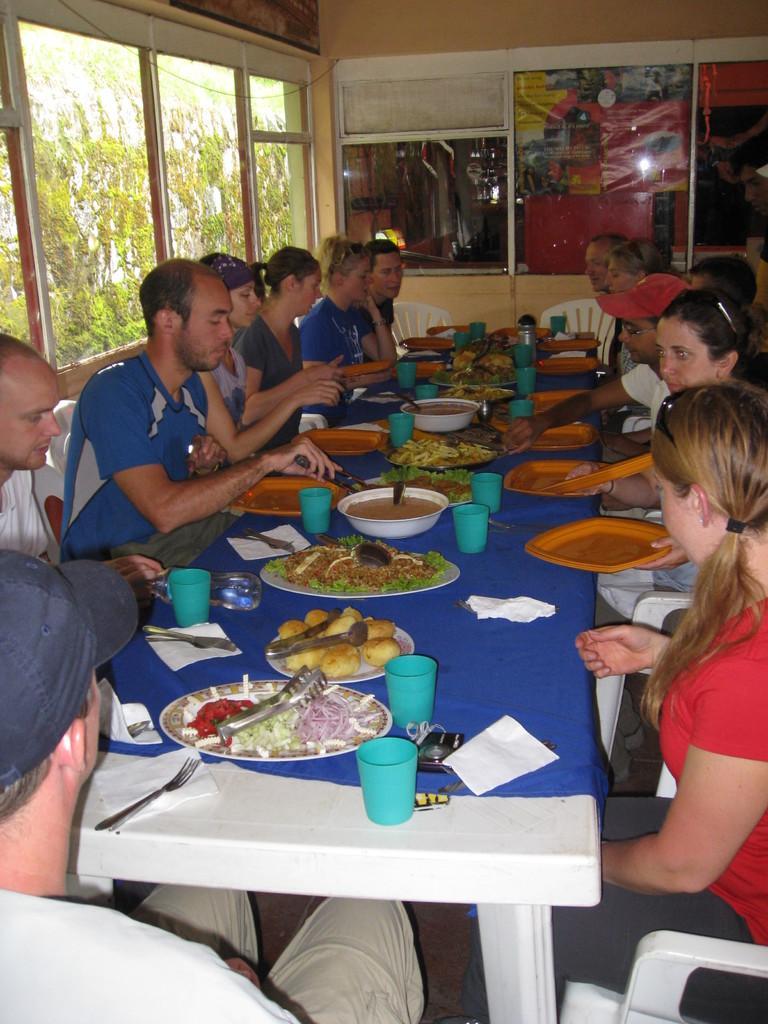Describe this image in one or two sentences. In this image I can see group of people sitting. In front of them there is a table. On the table there is a plate with food,cups,tissues,bowl and spoons. To the left there is a window. Through the window I can see there are some trees. 